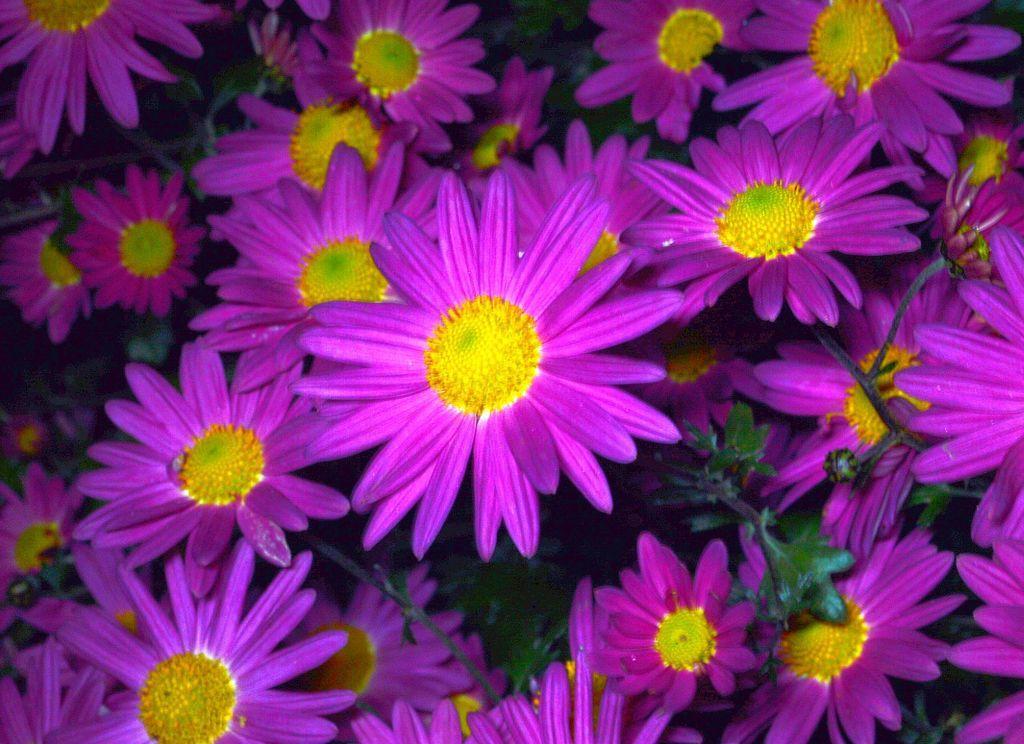Please provide a concise description of this image. This image consists of flowers in purple color. And the pollen grains are in yellow color. 